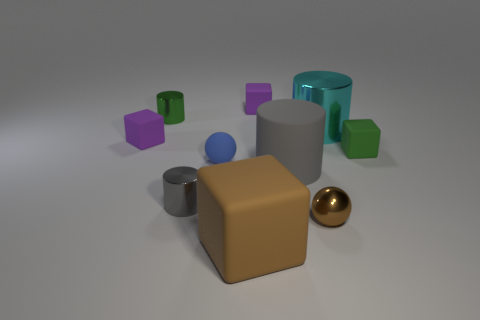Subtract all cyan cylinders. How many cylinders are left? 3 Subtract all green cylinders. How many cylinders are left? 3 Add 2 rubber balls. How many rubber balls exist? 3 Subtract 0 red cylinders. How many objects are left? 10 Subtract all cubes. How many objects are left? 6 Subtract 2 cylinders. How many cylinders are left? 2 Subtract all green balls. Subtract all green blocks. How many balls are left? 2 Subtract all gray blocks. How many green cylinders are left? 1 Subtract all shiny balls. Subtract all cyan shiny cylinders. How many objects are left? 8 Add 6 big gray things. How many big gray things are left? 7 